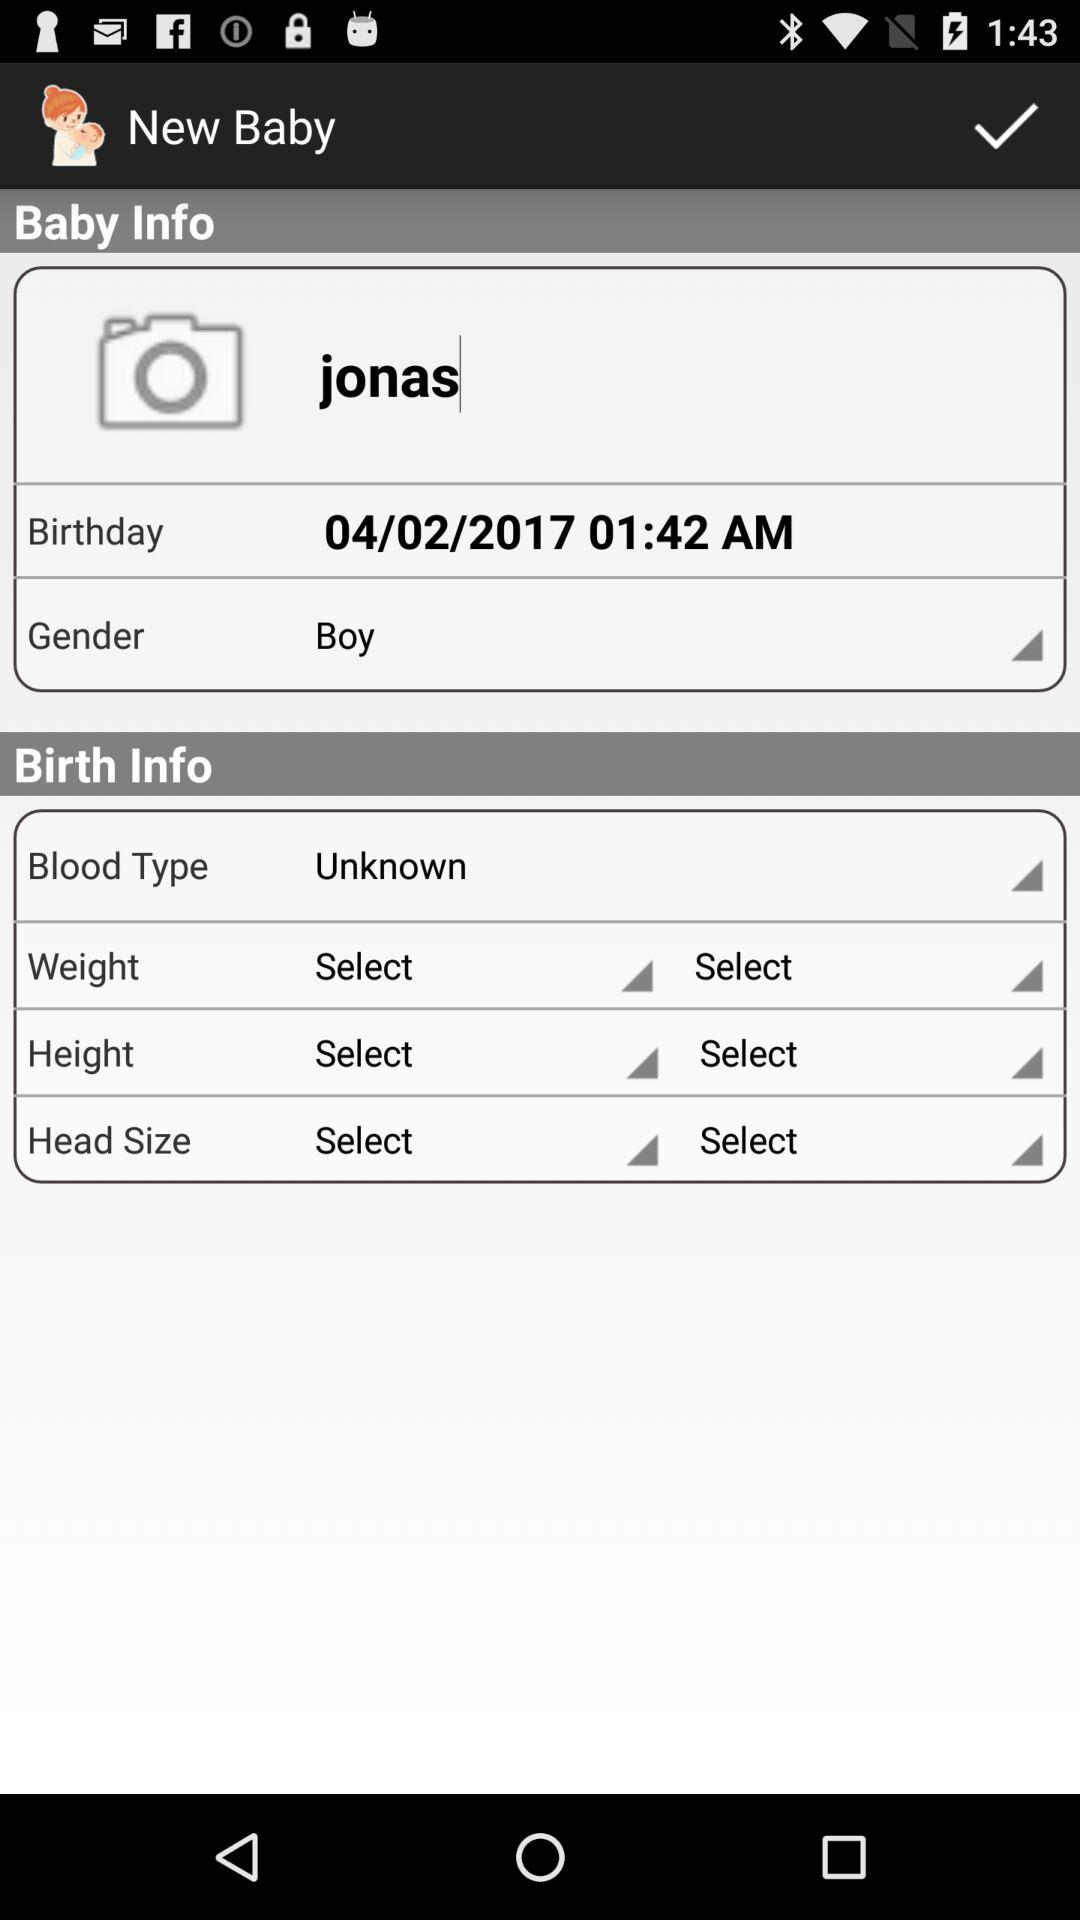What is the date of birth? The date of birth is 04/02/2017. 